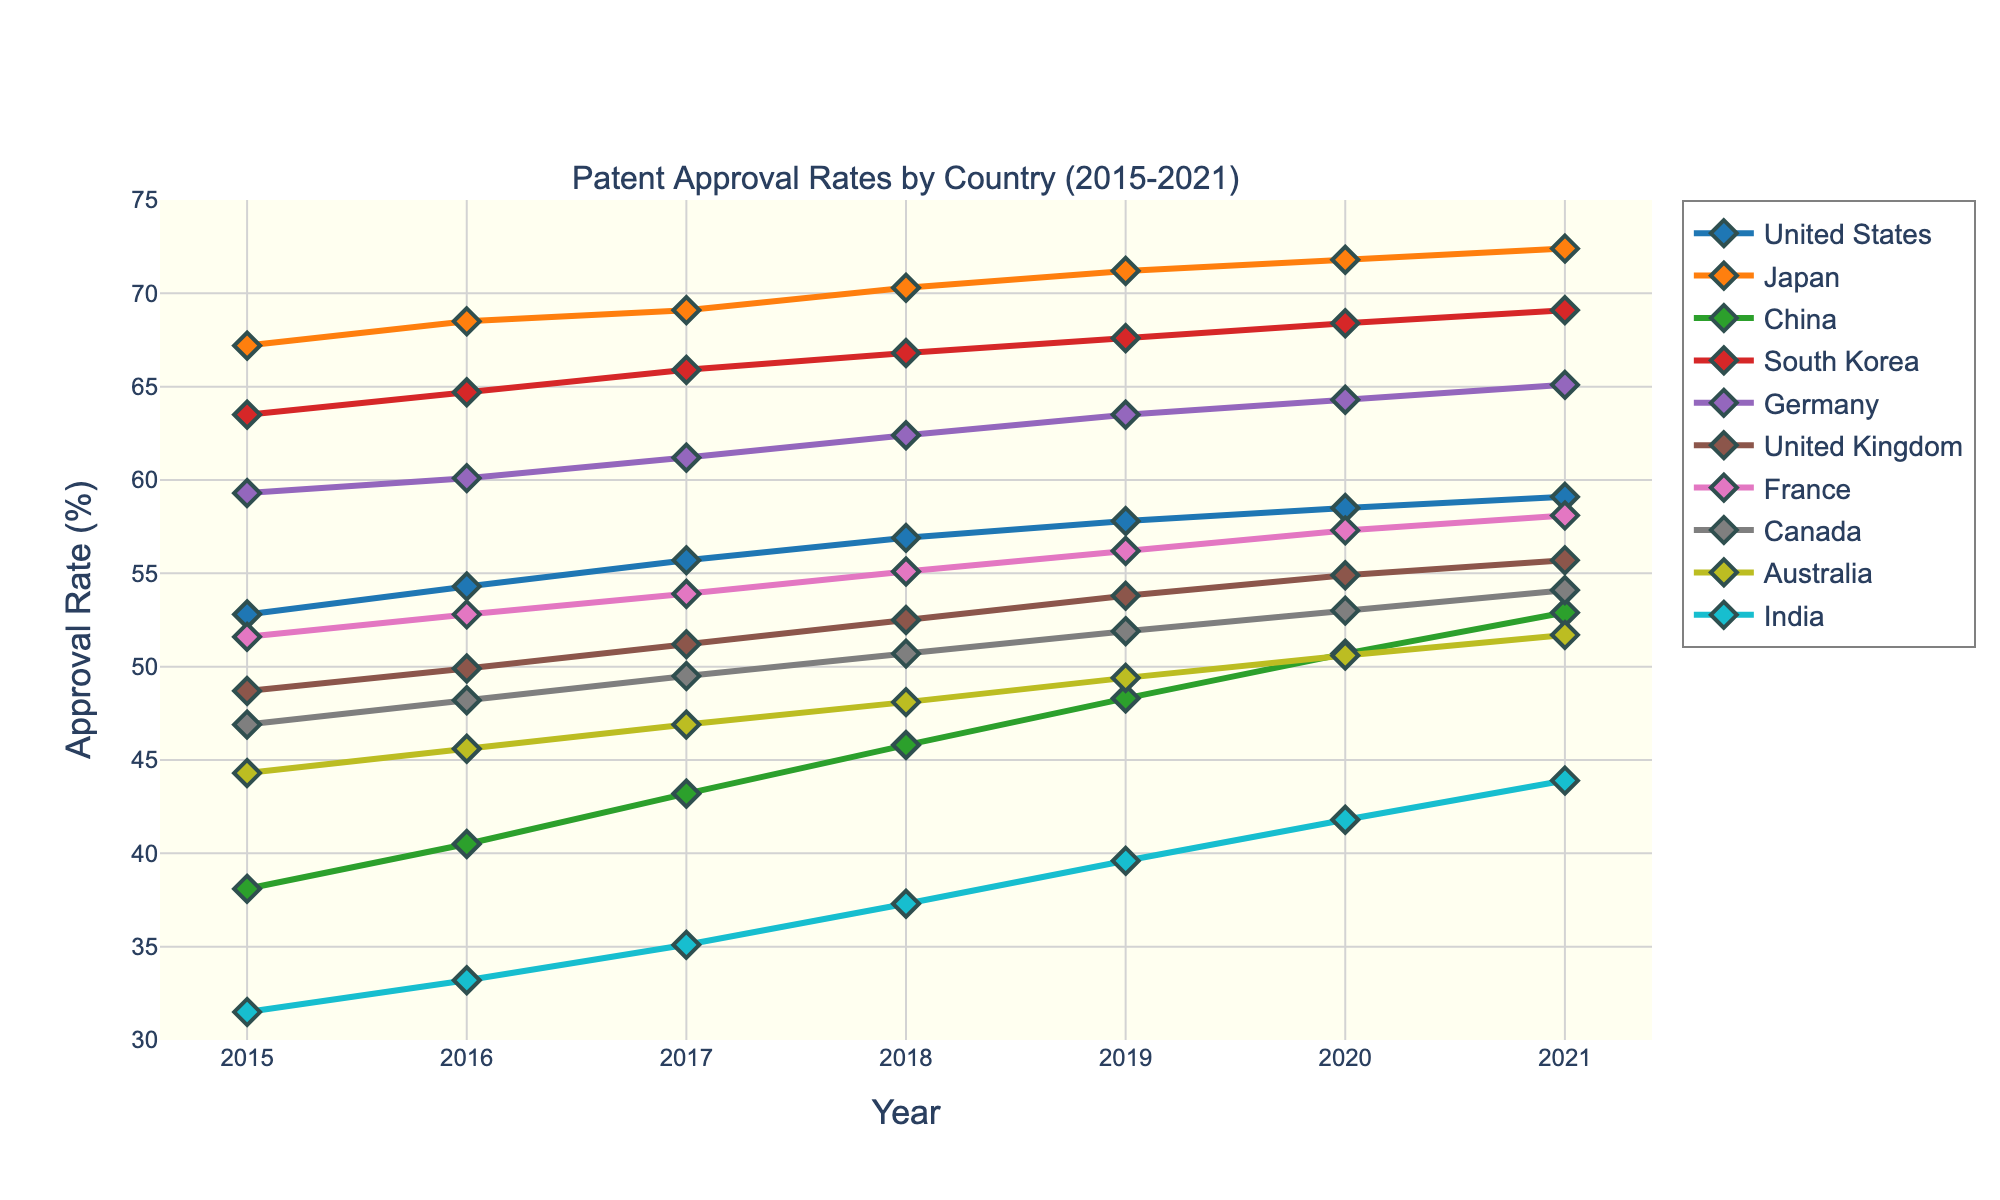Which country had the highest patent approval rate in 2021? To find the country with the highest patent approval rate in 2021, we look at the values for each country in the year 2021. The countries are Japan (72.4), South Korea (69.1), Germany (65.1), USA (59.1), France (58.1), UK (55.7), China (52.9), Canada (54.1), Australia (51.7), and India (43.9). Japan has the highest rate of 72.4%
Answer: Japan What is the difference in patent approval rate between India and China in 2021? Compare the approval rates for India (43.9) and China (52.9) in 2021. Subtract India’s rate from China’s rate: 52.9 - 43.9 = 9
Answer: 9 By how much did the United States' patent approval rate increase from 2015 to 2021? Check the rates for the United States in 2015 (52.8) and 2021 (59.1). Subtract the 2015 rate from the 2021 rate: 59.1 - 52.8 = 6.3
Answer: 6.3 Which country had a higher increase in its approval rate from 2015 to 2021: Germany or the United Kingdom? Calculate the increase for Germany (65.1 - 59.3 = 5.8) and the UK (55.7 - 48.7 = 7). The UK’s increase (7) is higher than Germany’s (5.8)
Answer: United Kingdom Among United States, China, and India, which country had the lowest patent approval rate in 2019? Check the 2019 rates for the USA (57.8), China (48.3), and India (39.6). India has the lowest approval rate
Answer: India What is the average patent approval rate for Japan from 2015 to 2021? Add the rates for Japan from 2015 to 2021 (67.2 + 68.5 + 69.1 + 70.3 + 71.2 + 71.8 + 72.4 = 490.5). Divide the sum by 7: 490.5 / 7 ≈ 70.07
Answer: 70.07 How does the approval rate change trend visually for South Korea from 2015 to 2021? South Korea’s approval rate shows a steady upward trend from 63.5 in 2015 to 69.1 in 2021, indicated by the increasing heights of the points along its line graph
Answer: steady increase Is there any country whose patent approval rate was always above 60% during the duration 2015-2021? Check the approval rates for each country from 2015 to 2021. Japan and South Korea consistently have rates above 60%
Answer: Japan, South Korea Which two countries had the closest approval rates in 2018? Look at the 2018 approval rates for all countries and find the closest values: Canada (50.7) and Australia (48.1), difference = 2.6; USA (56.9) and France (55.1), difference = 1.8. The closest pair is USA and France (difference = 1.8)
Answer: USA, France 